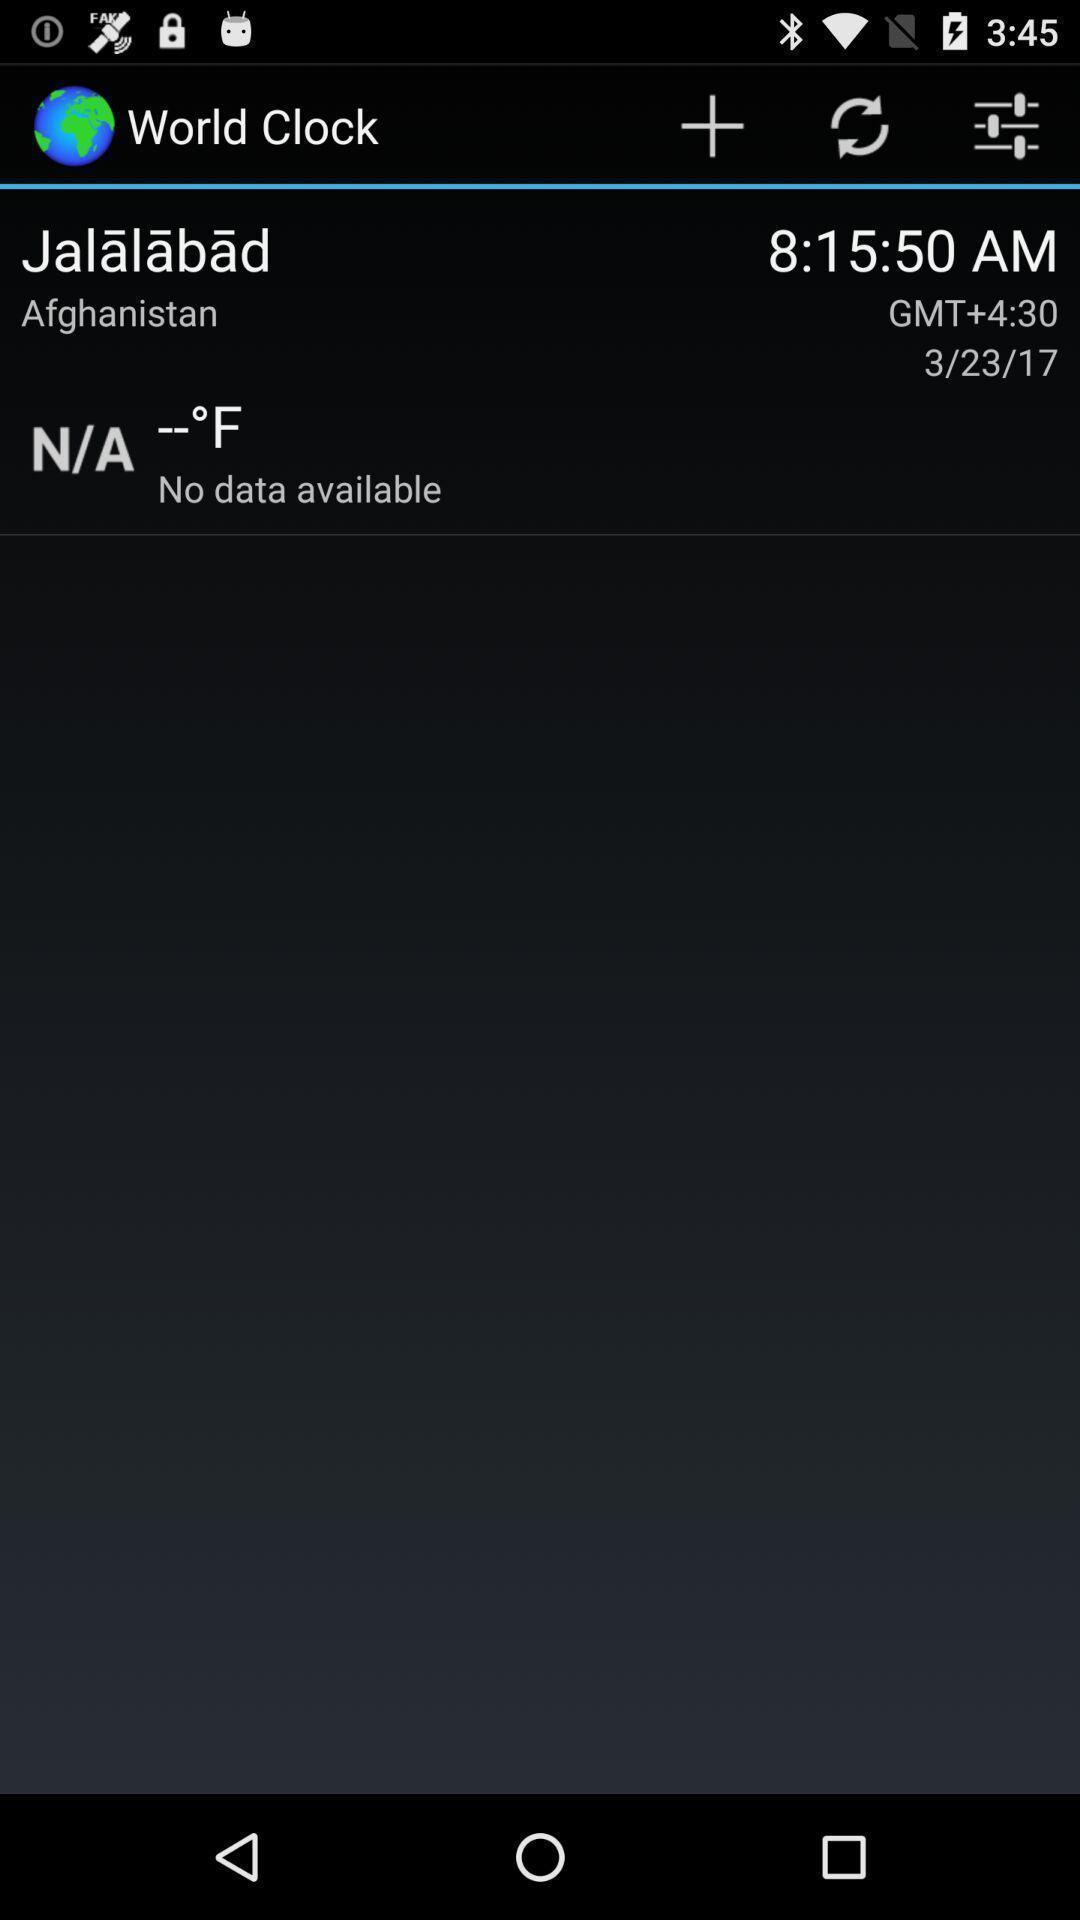Summarize the information in this screenshot. Page showing information about the timings. 